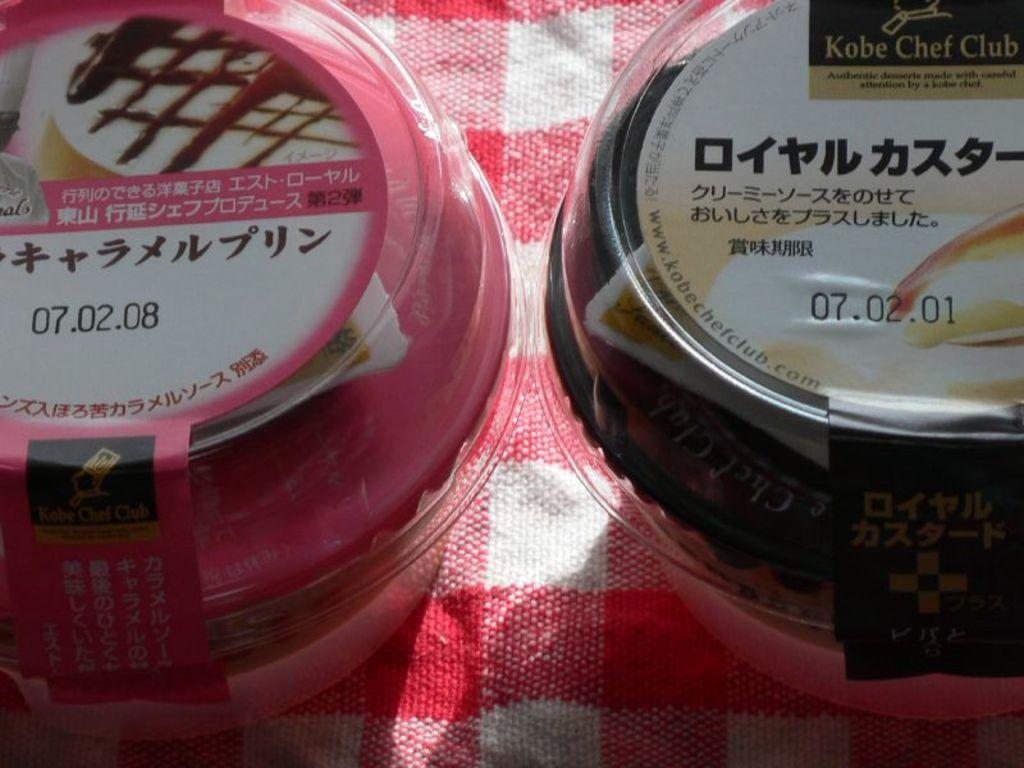<image>
Share a concise interpretation of the image provided. Two unopened desserts from the Kobe Chef Club and with Japanese writing on them stand next to each other. 